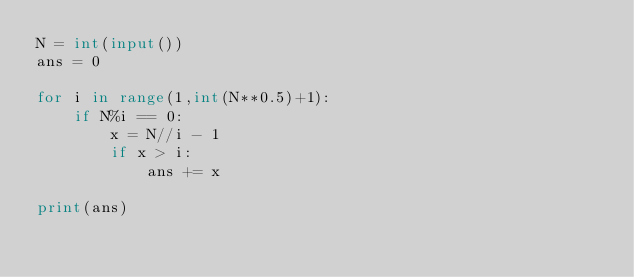Convert code to text. <code><loc_0><loc_0><loc_500><loc_500><_Python_>N = int(input())
ans = 0

for i in range(1,int(N**0.5)+1):
    if N%i == 0:
        x = N//i - 1
        if x > i:
            ans += x

print(ans)</code> 